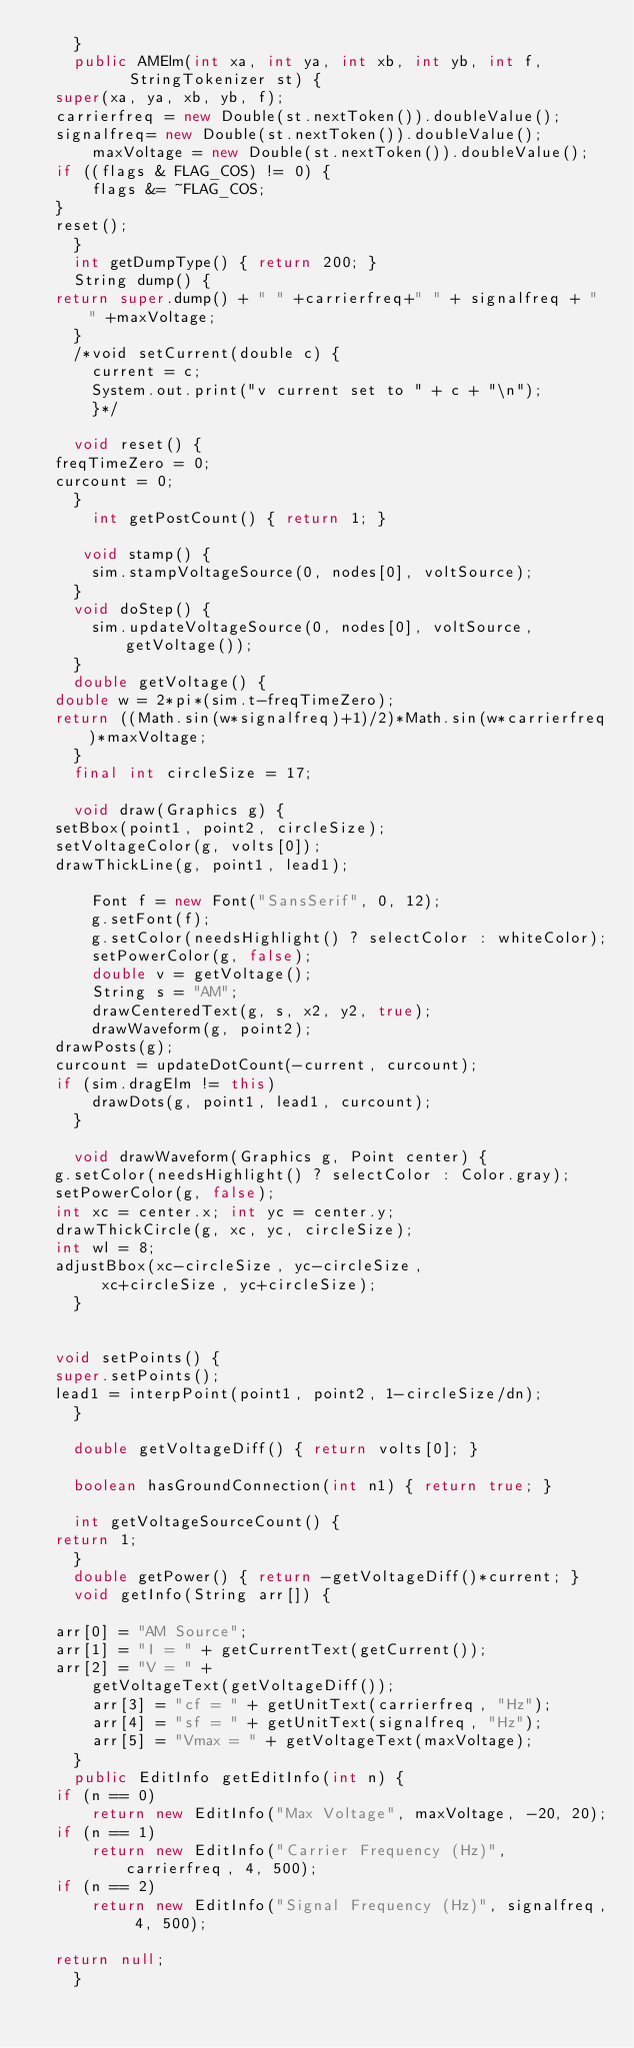Convert code to text. <code><loc_0><loc_0><loc_500><loc_500><_Java_>    }
    public AMElm(int xa, int ya, int xb, int yb, int f,
		      StringTokenizer st) {
	super(xa, ya, xb, yb, f);
	carrierfreq = new Double(st.nextToken()).doubleValue();
	signalfreq= new Double(st.nextToken()).doubleValue();
	    maxVoltage = new Double(st.nextToken()).doubleValue();
	if ((flags & FLAG_COS) != 0) {
	    flags &= ~FLAG_COS;
	}
	reset();
    }
    int getDumpType() { return 200; }
    String dump() {
	return super.dump() + " " +carrierfreq+" " + signalfreq + " " +maxVoltage;
    }
    /*void setCurrent(double c) {
      current = c;
      System.out.print("v current set to " + c + "\n");
      }*/

    void reset() {
	freqTimeZero = 0;
	curcount = 0;
    }
      int getPostCount() { return 1; }
	
     void stamp() {
	    sim.stampVoltageSource(0, nodes[0], voltSource);
    }
    void doStep() {
	    sim.updateVoltageSource(0, nodes[0], voltSource, getVoltage());
    }
    double getVoltage() {
	double w = 2*pi*(sim.t-freqTimeZero);
	return ((Math.sin(w*signalfreq)+1)/2)*Math.sin(w*carrierfreq)*maxVoltage;	
    }
    final int circleSize = 17;

    void draw(Graphics g) {
	setBbox(point1, point2, circleSize);
	setVoltageColor(g, volts[0]);
	drawThickLine(g, point1, lead1);

	    Font f = new Font("SansSerif", 0, 12);
	    g.setFont(f);
	    g.setColor(needsHighlight() ? selectColor : whiteColor);
	    setPowerColor(g, false);
	    double v = getVoltage();
	    String s = "AM";
	    drawCenteredText(g, s, x2, y2, true);
	    drawWaveform(g, point2);
	drawPosts(g);
	curcount = updateDotCount(-current, curcount);
	if (sim.dragElm != this)
	    drawDots(g, point1, lead1, curcount);
    }
	
    void drawWaveform(Graphics g, Point center) {
	g.setColor(needsHighlight() ? selectColor : Color.gray);
	setPowerColor(g, false);
	int xc = center.x; int yc = center.y;
	drawThickCircle(g, xc, yc, circleSize);
	int wl = 8;
	adjustBbox(xc-circleSize, yc-circleSize,
		   xc+circleSize, yc+circleSize);
    }


  void setPoints() {
	super.setPoints();
	lead1 = interpPoint(point1, point2, 1-circleSize/dn);
    }
    
    double getVoltageDiff() { return volts[0]; }
   
    boolean hasGroundConnection(int n1) { return true; }
	
    int getVoltageSourceCount() {
	return 1;
    }
    double getPower() { return -getVoltageDiff()*current; }
    void getInfo(String arr[]) {
	
	arr[0] = "AM Source";
	arr[1] = "I = " + getCurrentText(getCurrent());
	arr[2] = "V = " +
	    getVoltageText(getVoltageDiff());
	    arr[3] = "cf = " + getUnitText(carrierfreq, "Hz");
	    arr[4] = "sf = " + getUnitText(signalfreq, "Hz");
	    arr[5] = "Vmax = " + getVoltageText(maxVoltage);
    }
    public EditInfo getEditInfo(int n) {
	if (n == 0)
	    return new EditInfo("Max Voltage", maxVoltage, -20, 20);
	if (n == 1)
	    return new EditInfo("Carrier Frequency (Hz)", carrierfreq, 4, 500);
	if (n == 2)
	    return new EditInfo("Signal Frequency (Hz)", signalfreq, 4, 500);
	
	return null;
    }</code> 